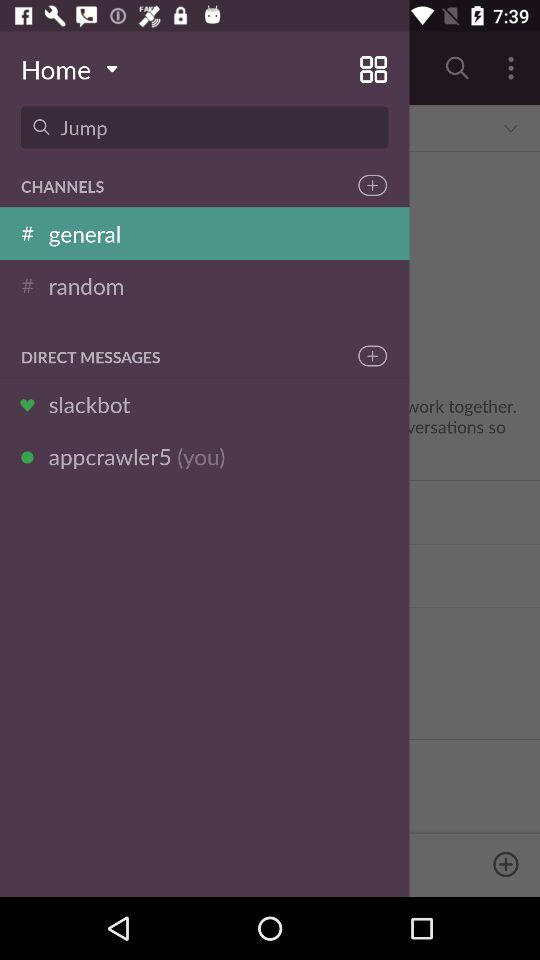What is the username? The username is "appcrawler5". 